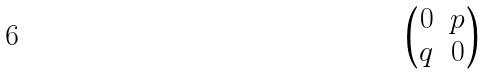<formula> <loc_0><loc_0><loc_500><loc_500>\begin{pmatrix} 0 & p \\ q & 0 \end{pmatrix}</formula> 